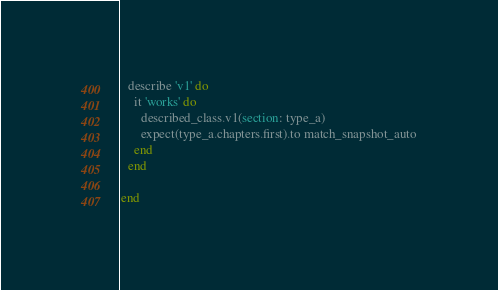Convert code to text. <code><loc_0><loc_0><loc_500><loc_500><_Ruby_>
  describe 'v1' do
    it 'works' do
      described_class.v1(section: type_a)
      expect(type_a.chapters.first).to match_snapshot_auto
    end
  end

end
</code> 